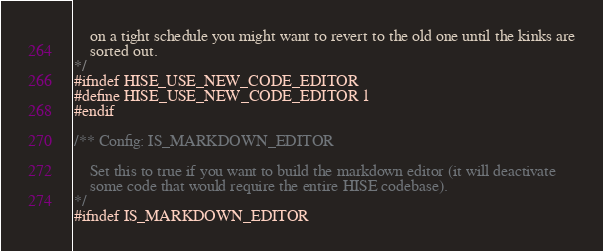Convert code to text. <code><loc_0><loc_0><loc_500><loc_500><_C_>	on a tight schedule you might want to revert to the old one until the kinks are
	sorted out.
*/
#ifndef HISE_USE_NEW_CODE_EDITOR
#define HISE_USE_NEW_CODE_EDITOR 1
#endif

/** Config: IS_MARKDOWN_EDITOR

	Set this to true if you want to build the markdown editor (it will deactivate
	some code that would require the entire HISE codebase).
*/
#ifndef IS_MARKDOWN_EDITOR</code> 